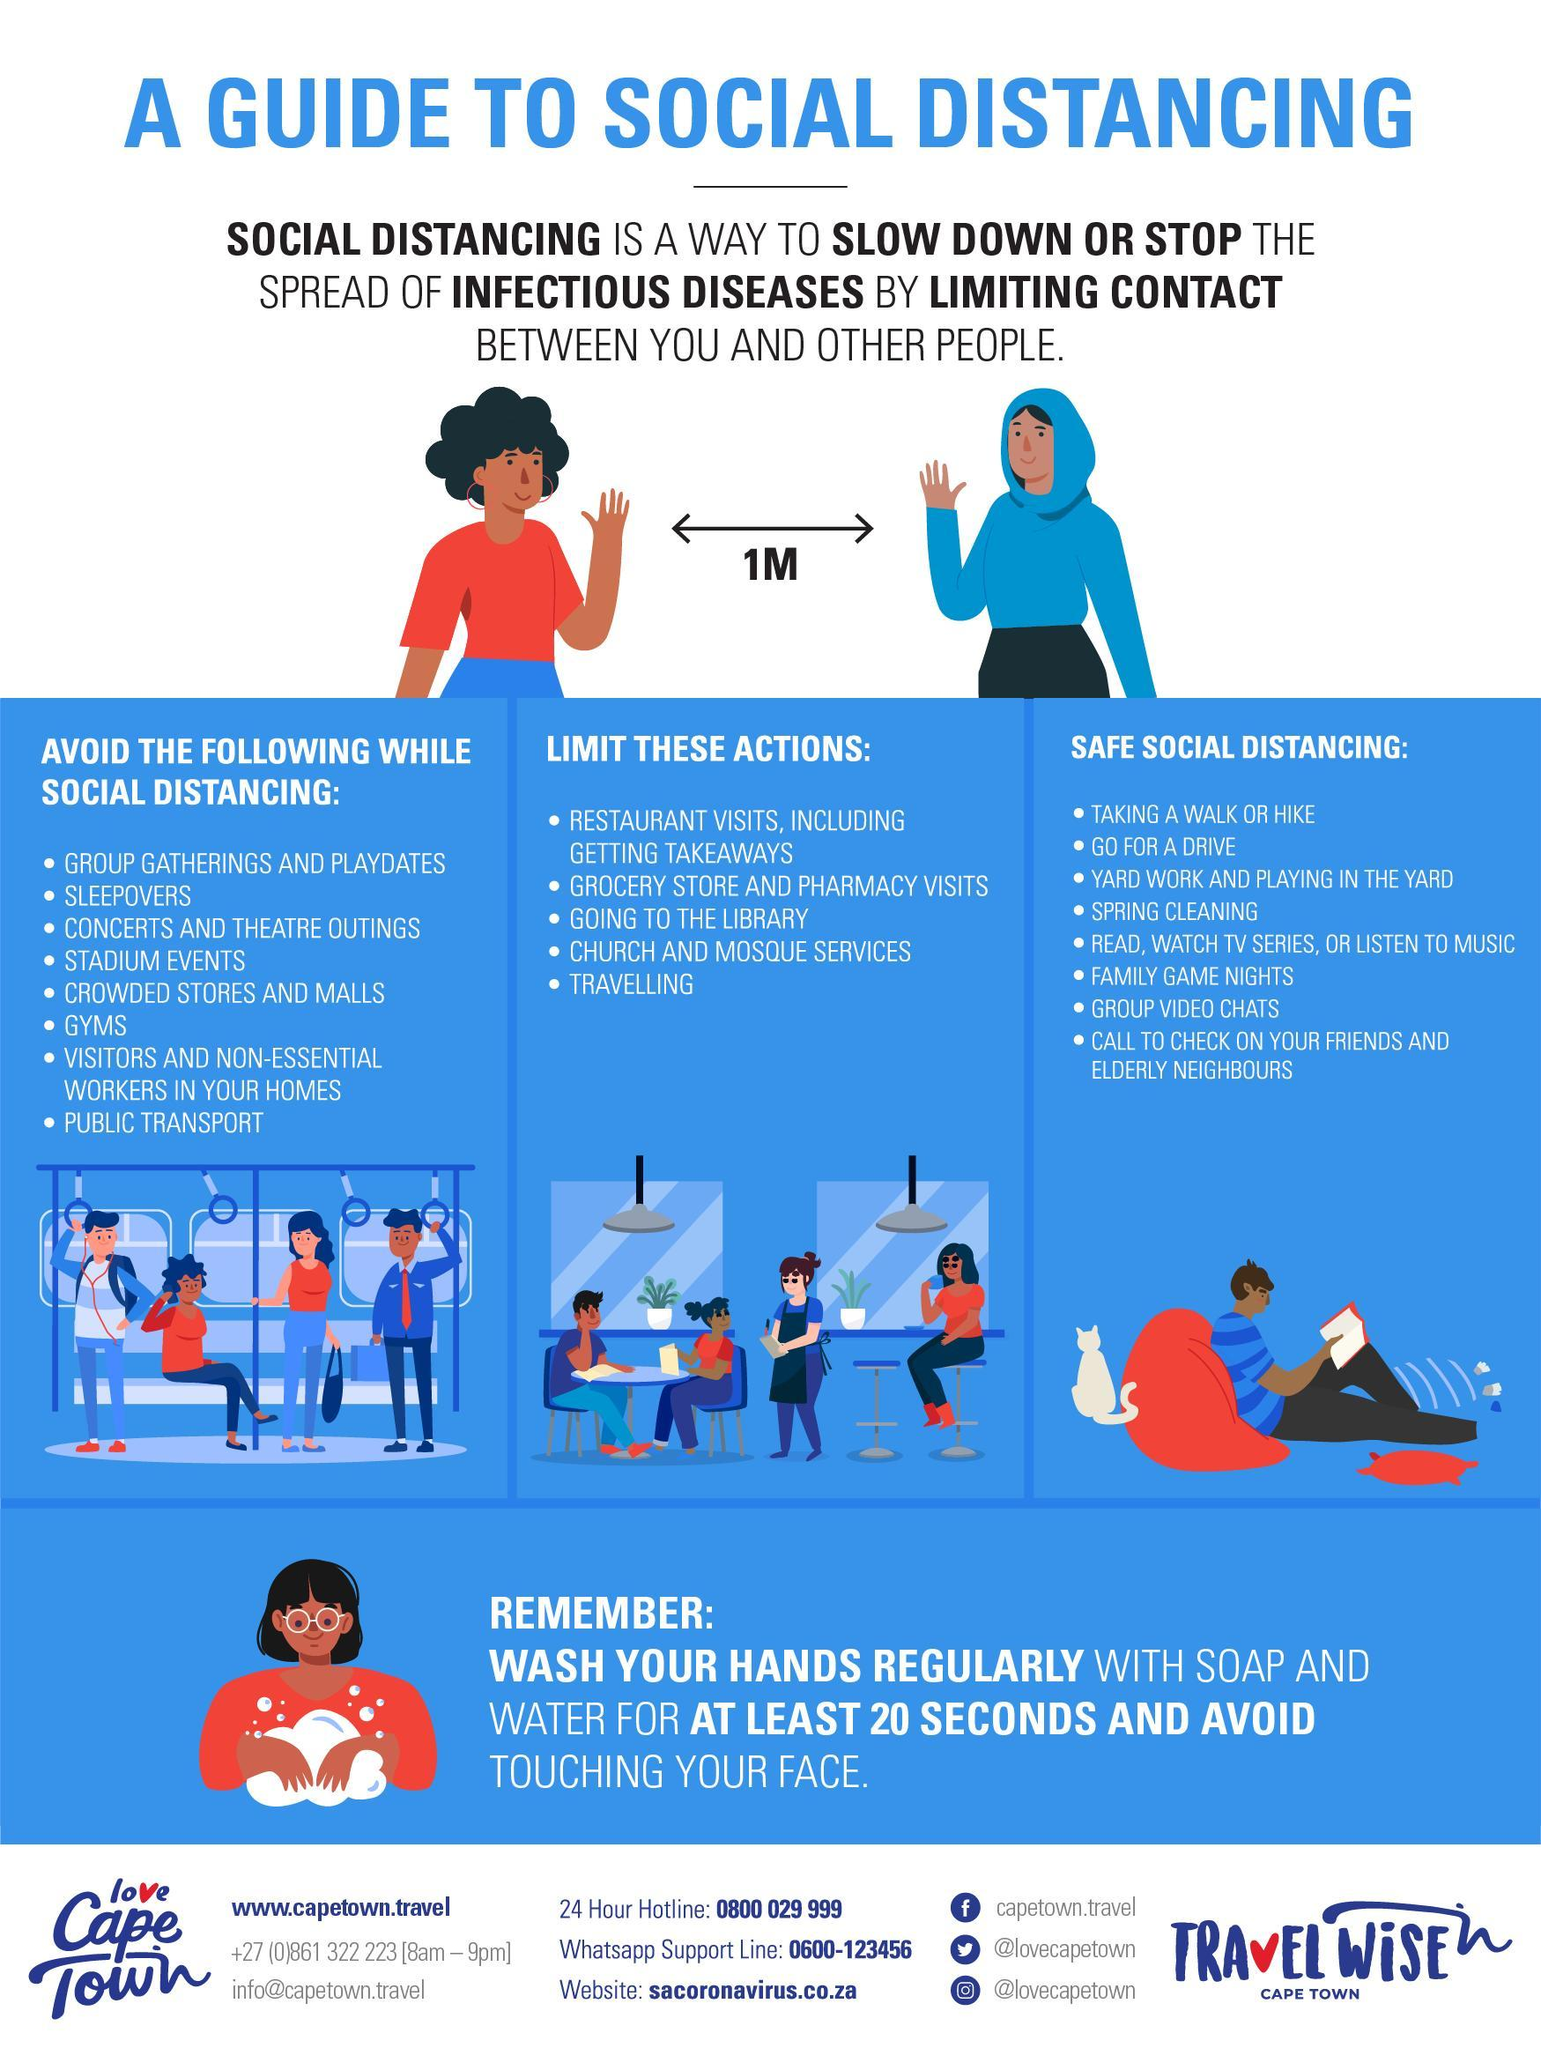What is the minimum safe distance to be maintained between yourself & others inorder to control the spread of COVID-19 virus?
Answer the question with a short phrase. 1M 